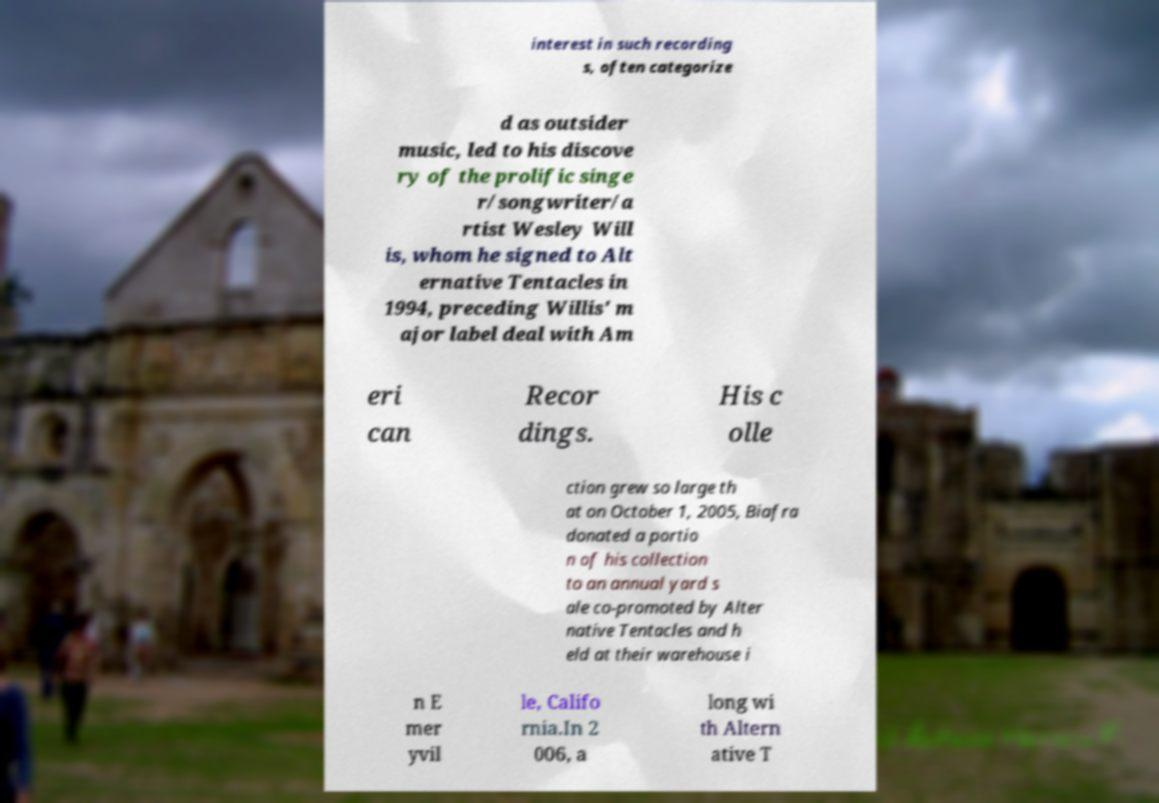Can you accurately transcribe the text from the provided image for me? interest in such recording s, often categorize d as outsider music, led to his discove ry of the prolific singe r/songwriter/a rtist Wesley Will is, whom he signed to Alt ernative Tentacles in 1994, preceding Willis' m ajor label deal with Am eri can Recor dings. His c olle ction grew so large th at on October 1, 2005, Biafra donated a portio n of his collection to an annual yard s ale co-promoted by Alter native Tentacles and h eld at their warehouse i n E mer yvil le, Califo rnia.In 2 006, a long wi th Altern ative T 